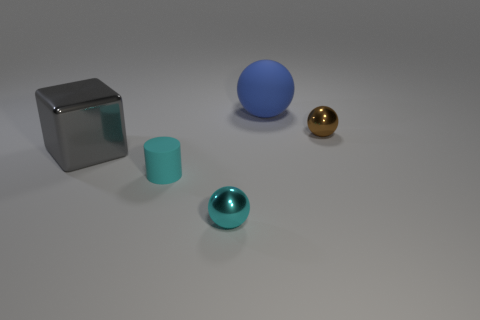What is the shape of the big object in front of the blue object?
Provide a succinct answer. Cube. How many things are both on the left side of the blue object and on the right side of the cyan rubber object?
Provide a short and direct response. 1. Is there a small blue cube that has the same material as the large gray cube?
Your answer should be very brief. No. What size is the metallic thing that is the same color as the small matte cylinder?
Provide a succinct answer. Small. What number of cylinders are tiny cyan matte objects or large blue objects?
Offer a terse response. 1. The gray metal cube is what size?
Your answer should be very brief. Large. How many blue balls are left of the metallic block?
Ensure brevity in your answer.  0. There is a metallic ball behind the big object that is on the left side of the cyan rubber cylinder; what is its size?
Offer a very short reply. Small. There is a matte thing in front of the brown shiny ball; is its shape the same as the small shiny thing that is right of the small cyan metal thing?
Offer a terse response. No. There is a big object that is behind the object right of the large blue matte ball; what is its shape?
Make the answer very short. Sphere. 